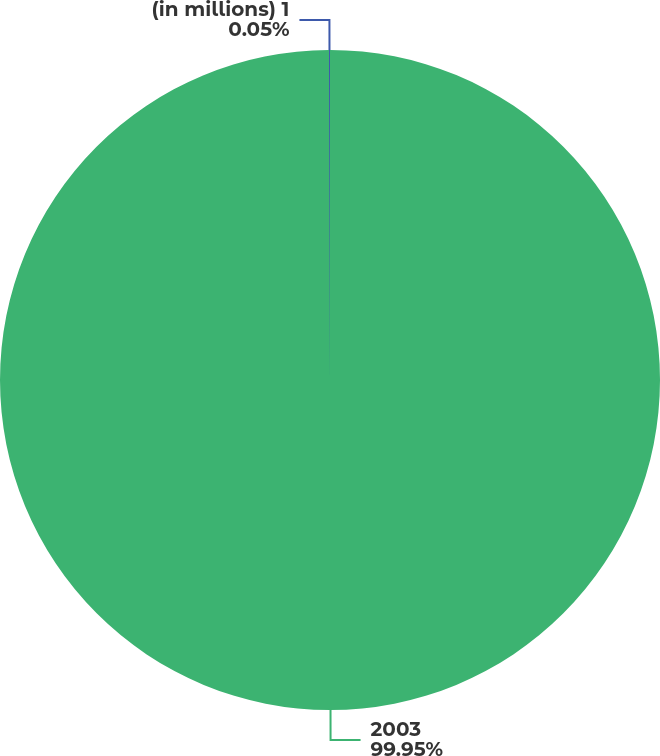Convert chart to OTSL. <chart><loc_0><loc_0><loc_500><loc_500><pie_chart><fcel>2003<fcel>(in millions) 1<nl><fcel>99.95%<fcel>0.05%<nl></chart> 